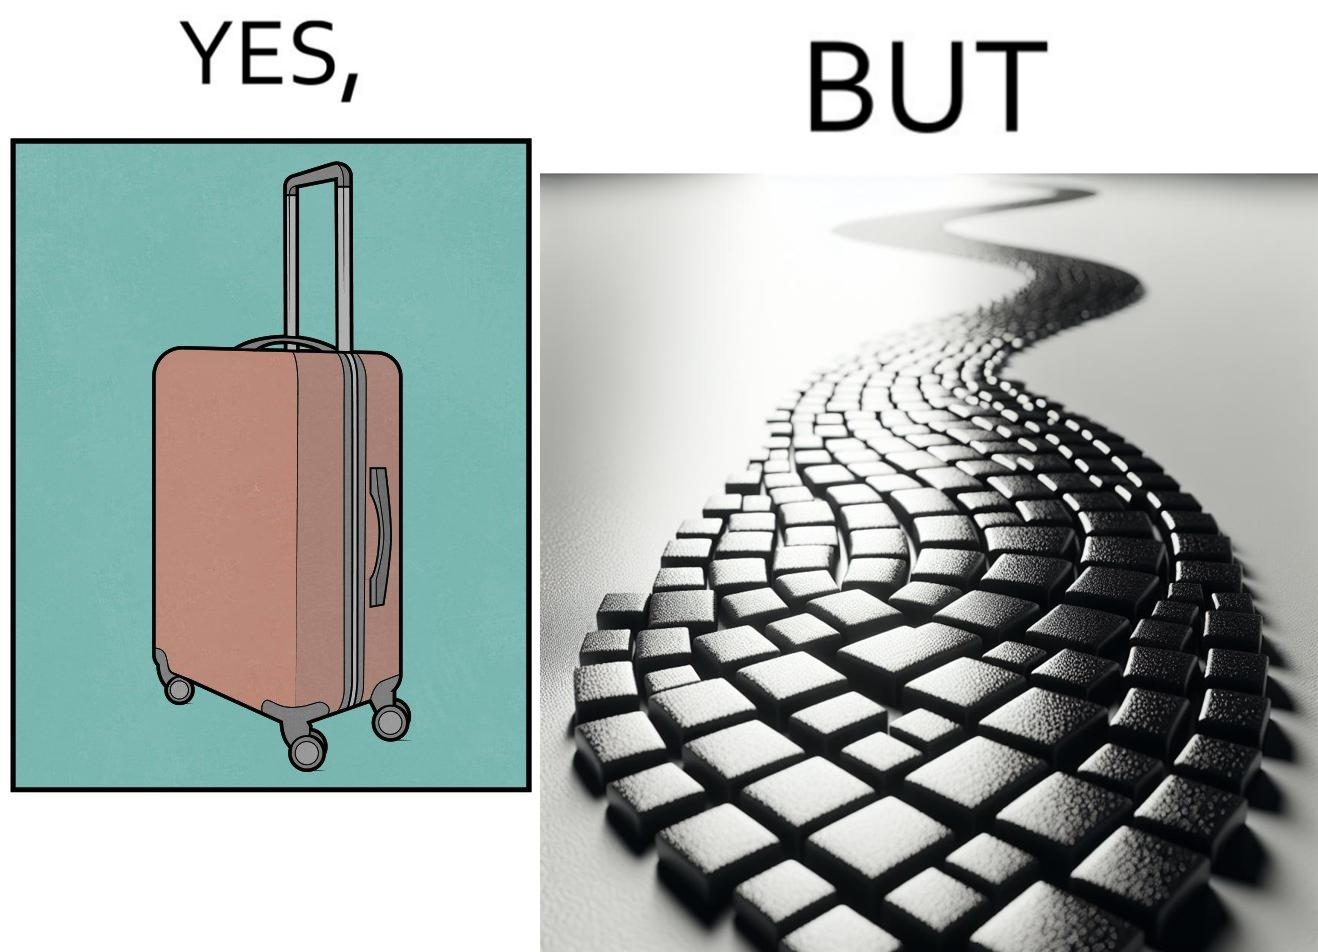Is this image satirical or non-satirical? Yes, this image is satirical. 